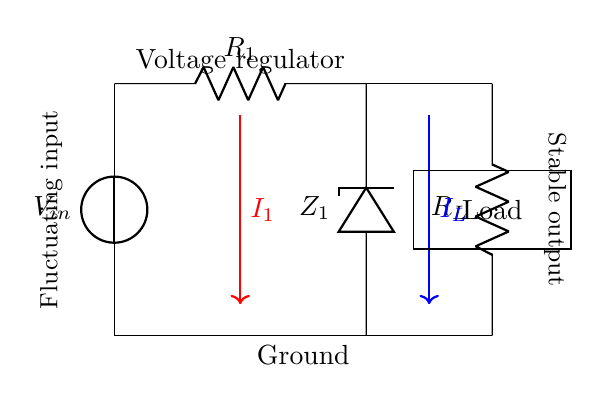What is the input voltage source labeled as? The input voltage source is labeled as V_in, which signifies the fluctuating voltage supplied to the circuit.
Answer: V_in What component is represented by Z_1? Z_1 is a Zener diode, which is used for voltage regulation in the circuit to ensure a stable output voltage regardless of fluctuations in input voltage.
Answer: Zener diode What is the purpose of resistor R_1? R_1 is a resistor that limits the current flowing into the Zener diode to protect it from excessive current which could lead to failure.
Answer: Current limiting What does the arrow from I_1 indicate? The arrow from I_1 indicates the direction of current flow into the circuit, which goes through R_1 before reaching the Zener diode.
Answer: Current direction How many resistors are in the circuit? There are two resistors in the circuit: R_1 and R_L, serving different functions; R_1 is for current limiting while R_L is the load resistor.
Answer: Two What is the output side of the circuit labeled as? The output side of the circuit is labeled as stable output, indicating that it provides a consistent voltage to the load connected.
Answer: Stable output What happens to the voltage across the load when the input voltage fluctuates? When the input voltage fluctuates, the Zener diode stabilizes the voltage across the load, preventing it from experiencing fluctuations and ensuring it receives a constant voltage.
Answer: Voltage stabilization 